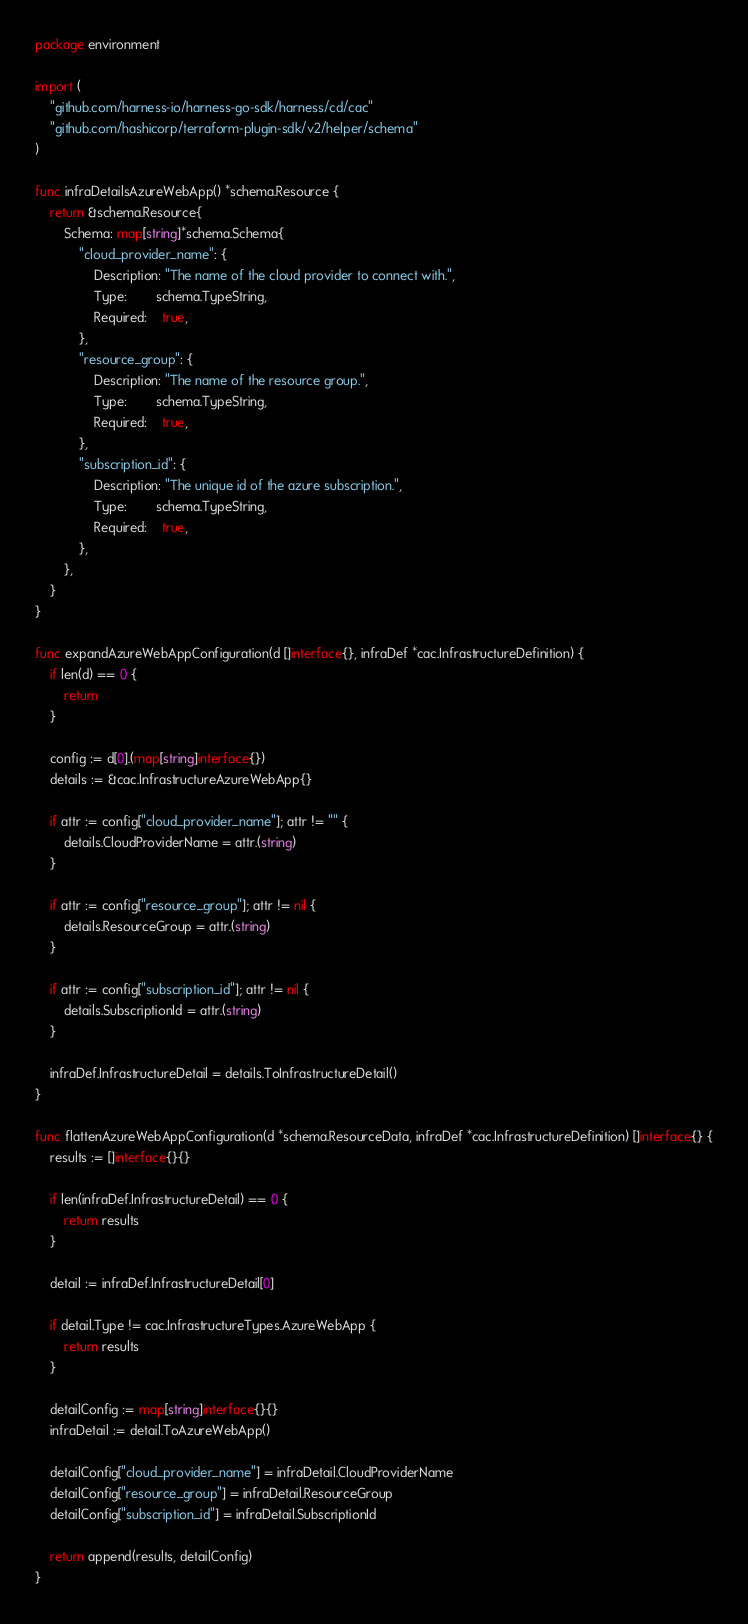<code> <loc_0><loc_0><loc_500><loc_500><_Go_>package environment

import (
	"github.com/harness-io/harness-go-sdk/harness/cd/cac"
	"github.com/hashicorp/terraform-plugin-sdk/v2/helper/schema"
)

func infraDetailsAzureWebApp() *schema.Resource {
	return &schema.Resource{
		Schema: map[string]*schema.Schema{
			"cloud_provider_name": {
				Description: "The name of the cloud provider to connect with.",
				Type:        schema.TypeString,
				Required:    true,
			},
			"resource_group": {
				Description: "The name of the resource group.",
				Type:        schema.TypeString,
				Required:    true,
			},
			"subscription_id": {
				Description: "The unique id of the azure subscription.",
				Type:        schema.TypeString,
				Required:    true,
			},
		},
	}
}

func expandAzureWebAppConfiguration(d []interface{}, infraDef *cac.InfrastructureDefinition) {
	if len(d) == 0 {
		return
	}

	config := d[0].(map[string]interface{})
	details := &cac.InfrastructureAzureWebApp{}

	if attr := config["cloud_provider_name"]; attr != "" {
		details.CloudProviderName = attr.(string)
	}

	if attr := config["resource_group"]; attr != nil {
		details.ResourceGroup = attr.(string)
	}

	if attr := config["subscription_id"]; attr != nil {
		details.SubscriptionId = attr.(string)
	}

	infraDef.InfrastructureDetail = details.ToInfrastructureDetail()
}

func flattenAzureWebAppConfiguration(d *schema.ResourceData, infraDef *cac.InfrastructureDefinition) []interface{} {
	results := []interface{}{}

	if len(infraDef.InfrastructureDetail) == 0 {
		return results
	}

	detail := infraDef.InfrastructureDetail[0]

	if detail.Type != cac.InfrastructureTypes.AzureWebApp {
		return results
	}

	detailConfig := map[string]interface{}{}
	infraDetail := detail.ToAzureWebApp()

	detailConfig["cloud_provider_name"] = infraDetail.CloudProviderName
	detailConfig["resource_group"] = infraDetail.ResourceGroup
	detailConfig["subscription_id"] = infraDetail.SubscriptionId

	return append(results, detailConfig)
}
</code> 